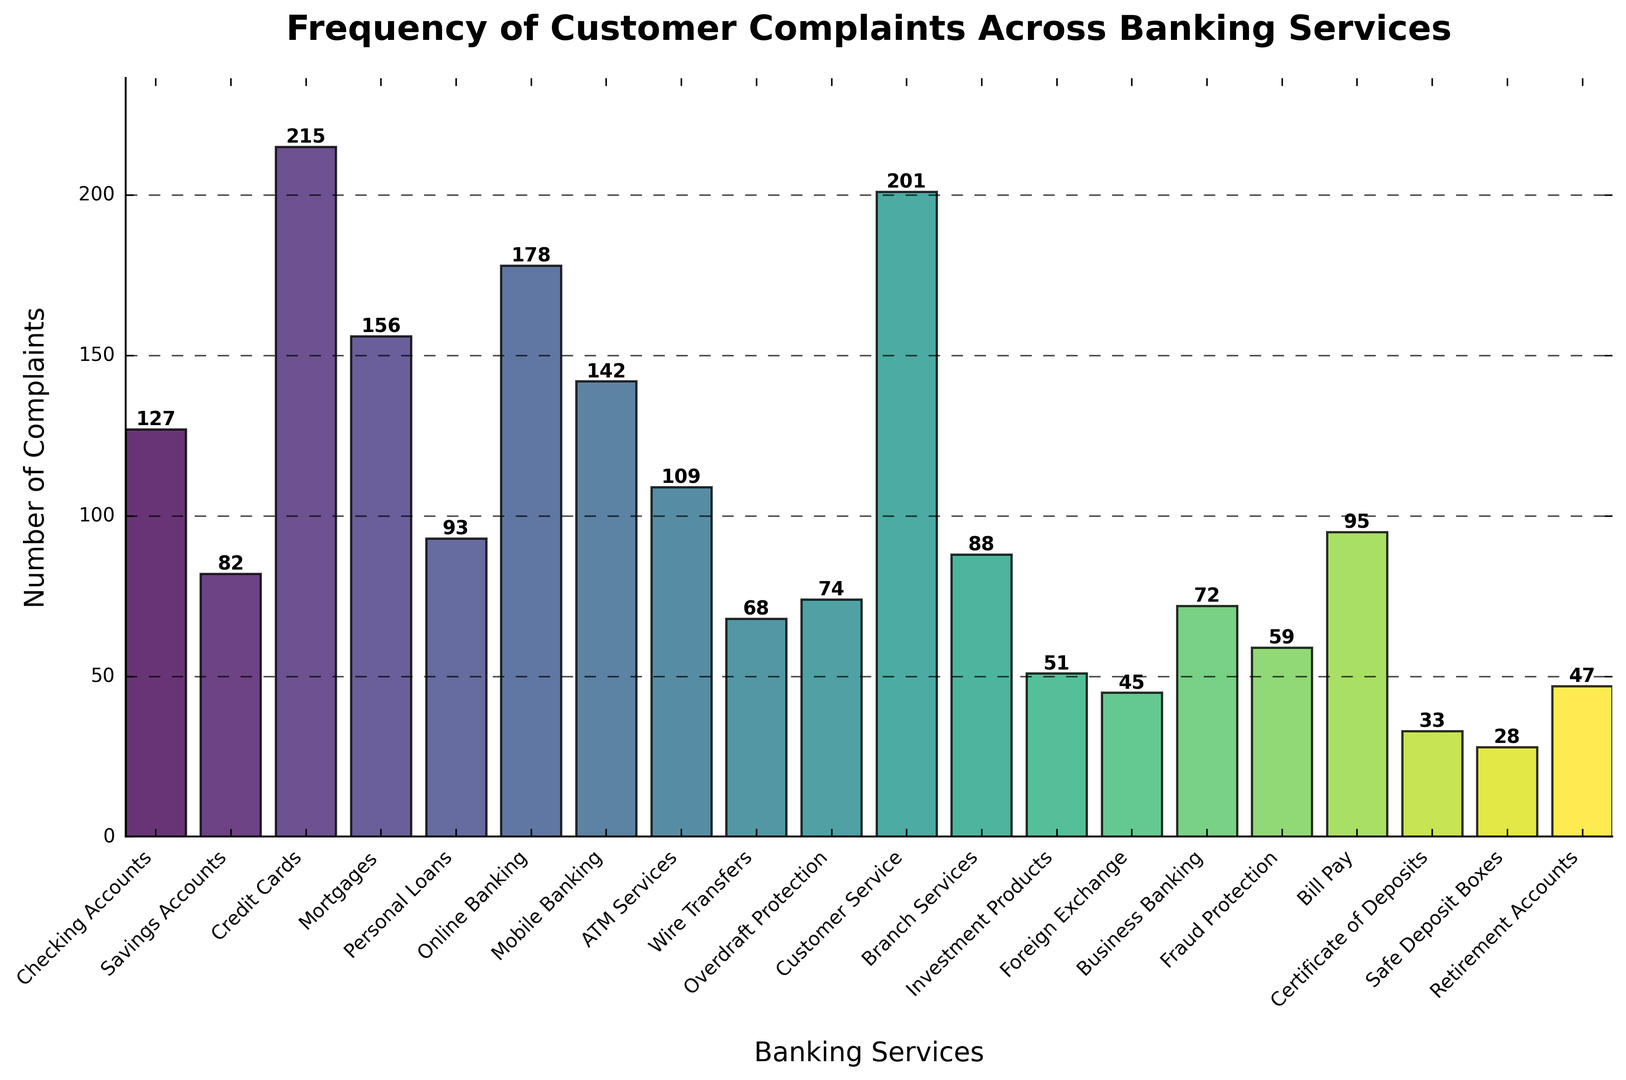Which banking service received the highest number of customer complaints? Identify the bar with the greatest height. The tallest bar is for Credit Cards with 215 complaints.
Answer: Credit Cards Which banking service received the lowest number of customer complaints? Identify the bar with the shortest height. The shortest bar is for Safe Deposit Boxes with 28 complaints.
Answer: Safe Deposit Boxes How many complaints were there for ATM Services compared to Wire Transfers? Find the bars for ATM Services and Wire Transfers and compare their heights. ATM Services had 109 complaints, while Wire Transfers had 68 complaints, so ATM Services received more complaints.
Answer: ATM Services had 41 more complaints What is the total number of complaints for Credit Cards and Mortgages? Look at the height of the bars for Credit Cards and Mortgages. The bar for Credit Cards shows 215 complaints, and the bar for Mortgages shows 156 complaints. Adding these together, 215 + 156 = 371.
Answer: 371 What is the difference in the number of complaints between Checking Accounts and Savings Accounts? Compare the heights of the bars for Checking Accounts and Savings Accounts. Checking Accounts had 127 complaints, and Savings Accounts had 82 complaints. Subtracting these, 127 - 82 = 45.
Answer: 45 Which banking services received more complaints than Online Banking? Look at the heights of the bars and find services with more than 178 complaints (Online Banking). Credit Cards and Customer Service have more complaints.
Answer: Credit Cards, Customer Service Are complaints about Mobile Banking higher or lower than ATM Services and by how much? Comparing the bars: Mobile Banking had 142 complaints, ATM Services had 109 complaints. So, 142 - 109 = 33.
Answer: Higher by 33 Which three services received the fewest complaints? Identify the three shortest bars. They represent Safe Deposit Boxes (28), Certificate of Deposits (33), and Investment Products (51).
Answer: Safe Deposit Boxes, Certificate of Deposits, Investment Products What is the average number of complaints across all banking services shown in the figure? Sum up the total complaints and divide by the number of services. Total complaints are 1,870, and there are 20 services. So, 1,870 / 20 = 93.5.
Answer: 93.5 